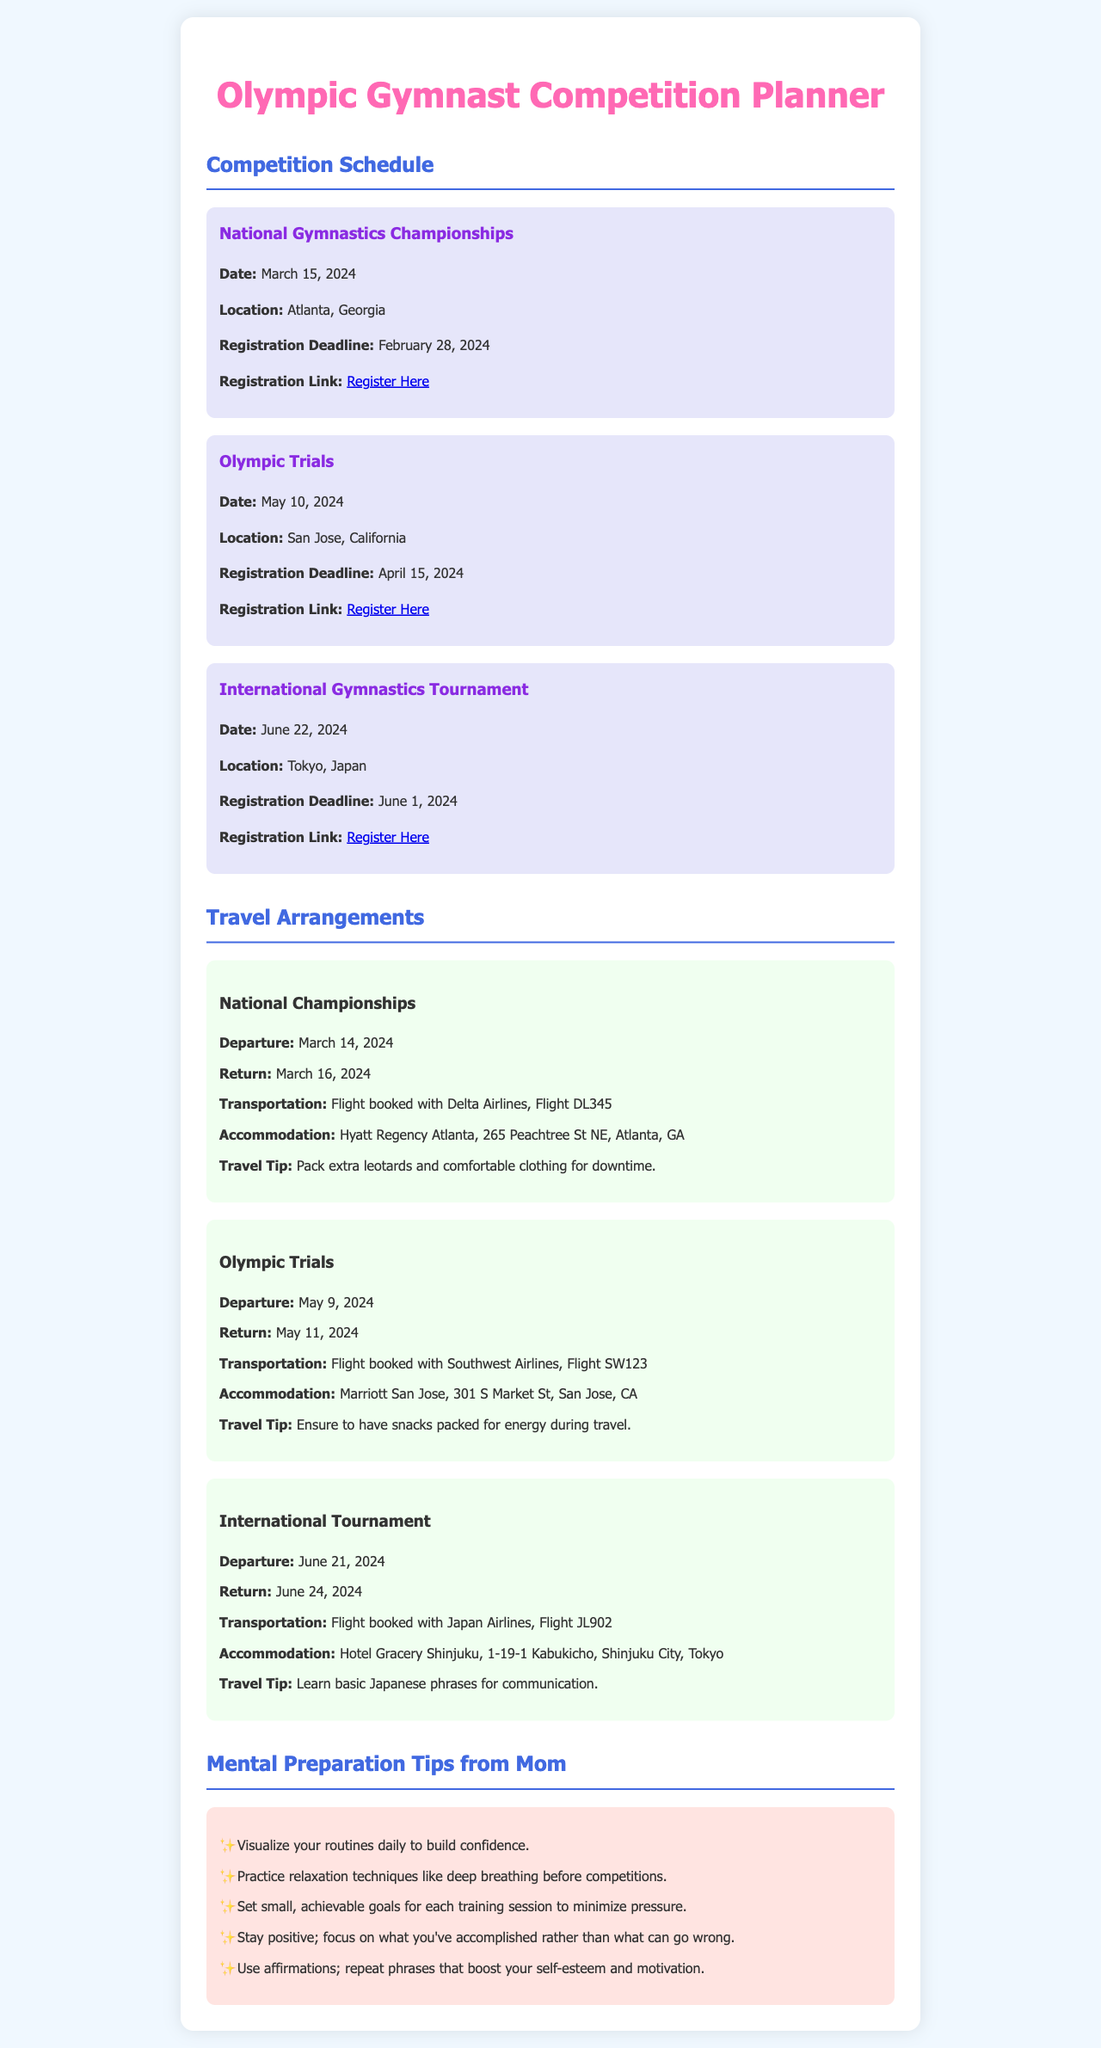What is the date of the National Gymnastics Championships? The date for the National Gymnastics Championships is mentioned in the document as March 15, 2024.
Answer: March 15, 2024 Where will the Olympic Trials be held? The location for the Olympic Trials is specified as San Jose, California in the document.
Answer: San Jose, California What is the registration deadline for the International Gymnastics Tournament? The registration deadline is shown as June 1, 2024, for the International Gymnastics Tournament.
Answer: June 1, 2024 What flight is booked for the National Championships? The document mentions Flight DL345 as the booked flight with Delta Airlines for the National Championships.
Answer: Flight DL345 Which hotel is booked for the Olympic Trials? The accommodation for the Olympic Trials is stated as Marriott San Jose in the document.
Answer: Marriott San Jose How many days will you stay in Tokyo for the International Tournament? The stay in Tokyo is from June 21, 2024, to June 24, 2024, which totals three days.
Answer: Three days What is a travel tip for the Olympic Trials? One of the travel tips provided in the document is to ensure to have snacks packed for energy during travel.
Answer: Have snacks packed What technique does mom suggest for relaxation before competitions? The document mentions practicing relaxation techniques like deep breathing as a suggestion from mom.
Answer: Deep breathing What is the main focus of the mental preparation tips? The mental preparation tips are designed to build confidence and manage pressure during competitions.
Answer: Build confidence 